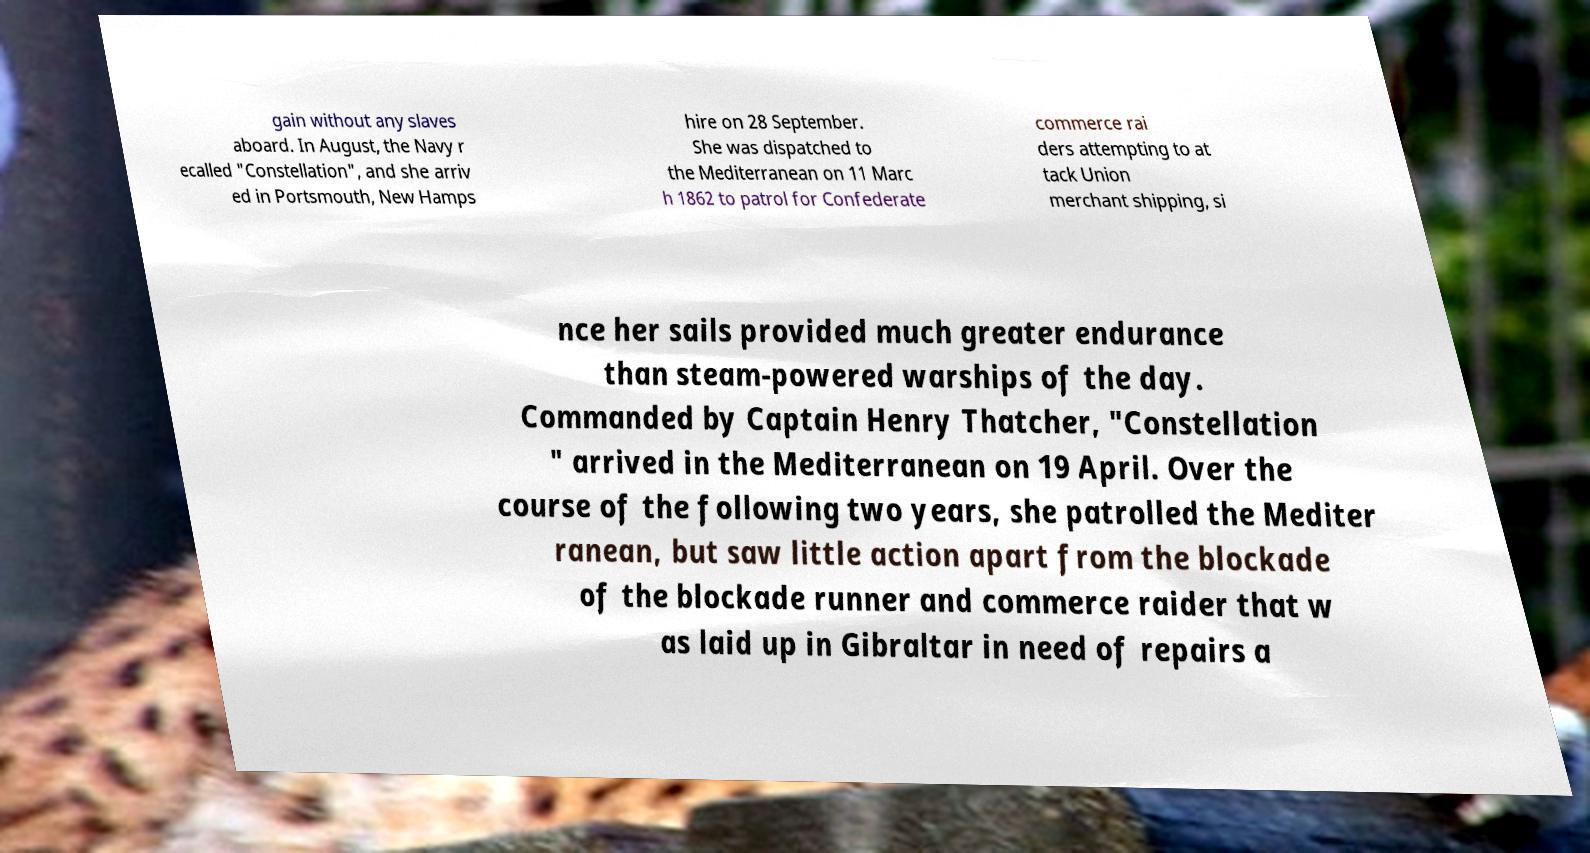Could you assist in decoding the text presented in this image and type it out clearly? gain without any slaves aboard. In August, the Navy r ecalled "Constellation", and she arriv ed in Portsmouth, New Hamps hire on 28 September. She was dispatched to the Mediterranean on 11 Marc h 1862 to patrol for Confederate commerce rai ders attempting to at tack Union merchant shipping, si nce her sails provided much greater endurance than steam-powered warships of the day. Commanded by Captain Henry Thatcher, "Constellation " arrived in the Mediterranean on 19 April. Over the course of the following two years, she patrolled the Mediter ranean, but saw little action apart from the blockade of the blockade runner and commerce raider that w as laid up in Gibraltar in need of repairs a 